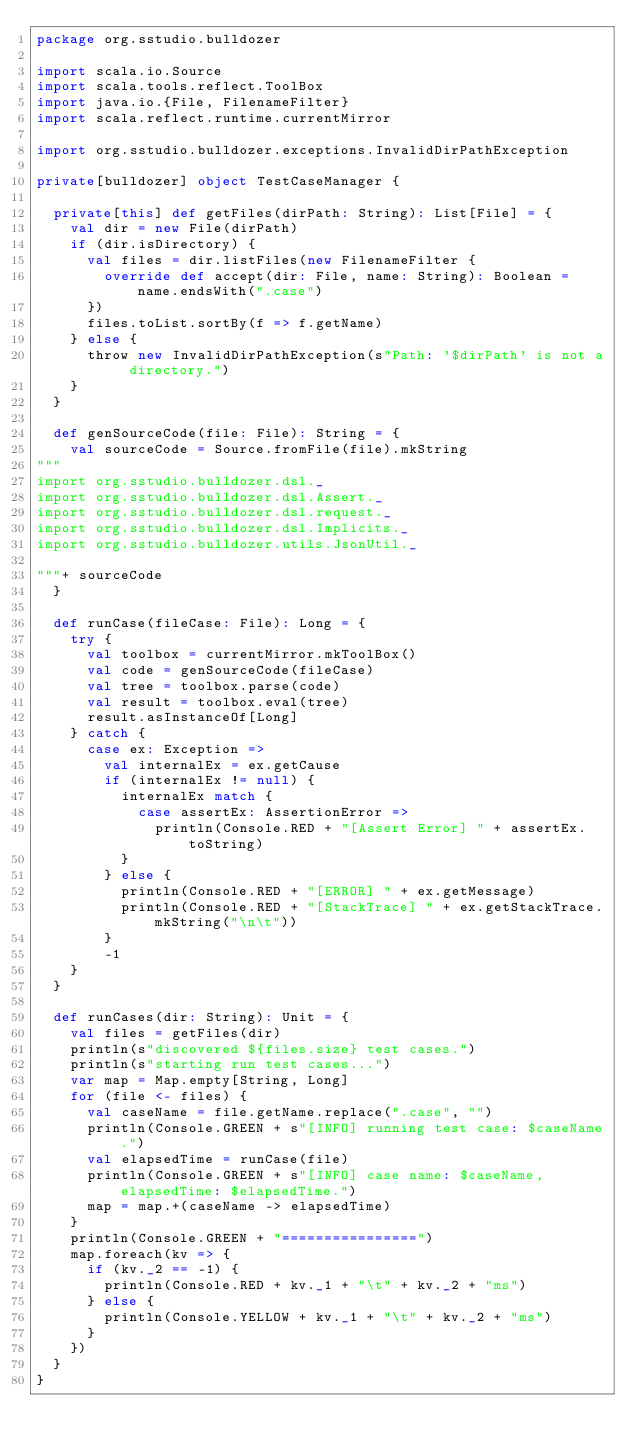<code> <loc_0><loc_0><loc_500><loc_500><_Scala_>package org.sstudio.bulldozer

import scala.io.Source
import scala.tools.reflect.ToolBox
import java.io.{File, FilenameFilter}
import scala.reflect.runtime.currentMirror

import org.sstudio.bulldozer.exceptions.InvalidDirPathException

private[bulldozer] object TestCaseManager {

  private[this] def getFiles(dirPath: String): List[File] = {
    val dir = new File(dirPath)
    if (dir.isDirectory) {
      val files = dir.listFiles(new FilenameFilter {
        override def accept(dir: File, name: String): Boolean = name.endsWith(".case")
      })
      files.toList.sortBy(f => f.getName)
    } else {
      throw new InvalidDirPathException(s"Path: '$dirPath' is not a directory.")
    }
  }

  def genSourceCode(file: File): String = {
    val sourceCode = Source.fromFile(file).mkString
"""
import org.sstudio.bulldozer.dsl._
import org.sstudio.bulldozer.dsl.Assert._
import org.sstudio.bulldozer.dsl.request._
import org.sstudio.bulldozer.dsl.Implicits._
import org.sstudio.bulldozer.utils.JsonUtil._

"""+ sourceCode
  }

  def runCase(fileCase: File): Long = {
    try {
      val toolbox = currentMirror.mkToolBox()
      val code = genSourceCode(fileCase)
      val tree = toolbox.parse(code)
      val result = toolbox.eval(tree)
      result.asInstanceOf[Long]
    } catch {
      case ex: Exception =>
        val internalEx = ex.getCause
        if (internalEx != null) {
          internalEx match {
            case assertEx: AssertionError =>
              println(Console.RED + "[Assert Error] " + assertEx.toString)
          }
        } else {
          println(Console.RED + "[ERROR] " + ex.getMessage)
          println(Console.RED + "[StackTrace] " + ex.getStackTrace.mkString("\n\t"))
        }
        -1
    }
  }

  def runCases(dir: String): Unit = {
    val files = getFiles(dir)
    println(s"discovered ${files.size} test cases.")
    println(s"starting run test cases...")
    var map = Map.empty[String, Long]
    for (file <- files) {
      val caseName = file.getName.replace(".case", "")
      println(Console.GREEN + s"[INFO] running test case: $caseName.")
      val elapsedTime = runCase(file)
      println(Console.GREEN + s"[INFO] case name: $caseName, elapsedTime: $elapsedTime.")
      map = map.+(caseName -> elapsedTime)
    }
    println(Console.GREEN + "================")
    map.foreach(kv => {
      if (kv._2 == -1) {
        println(Console.RED + kv._1 + "\t" + kv._2 + "ms")
      } else {
        println(Console.YELLOW + kv._1 + "\t" + kv._2 + "ms")
      }
    })
  }
}
</code> 